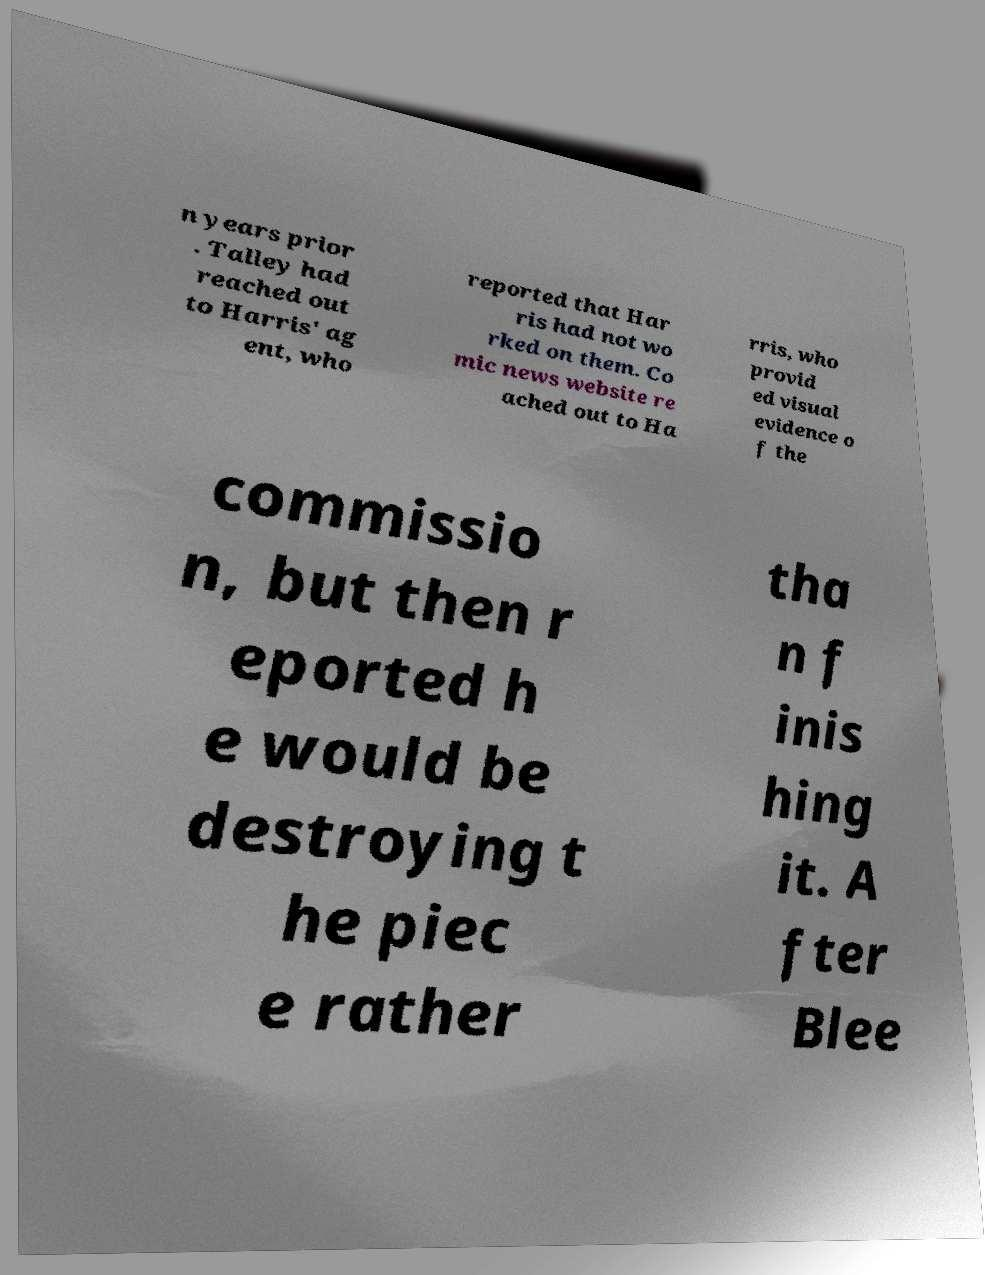For documentation purposes, I need the text within this image transcribed. Could you provide that? n years prior . Talley had reached out to Harris' ag ent, who reported that Har ris had not wo rked on them. Co mic news website re ached out to Ha rris, who provid ed visual evidence o f the commissio n, but then r eported h e would be destroying t he piec e rather tha n f inis hing it. A fter Blee 